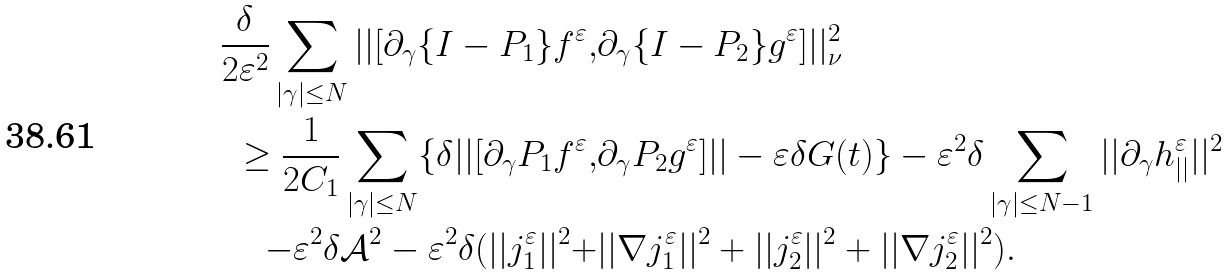Convert formula to latex. <formula><loc_0><loc_0><loc_500><loc_500>\frac { \delta } { 2 \varepsilon ^ { 2 } } \sum _ { | \gamma | \leq N } | | [ \partial _ { \gamma } { \{ I - P _ { 1 } \} f ^ { \varepsilon } } , & \partial _ { \gamma } { \{ I - P _ { 2 } \} g ^ { \varepsilon } } ] | | _ { \nu } ^ { 2 } \\ \geq \frac { 1 } { 2 C _ { 1 } } \sum _ { | \gamma | \leq N } \{ \delta | | [ \partial _ { \gamma } { P _ { 1 } f ^ { \varepsilon } } , & \partial _ { \gamma } { P _ { 2 } g ^ { \varepsilon } } ] | | - \varepsilon \delta G ( t ) \} - \varepsilon ^ { 2 } \delta \sum _ { | \gamma | \leq N - 1 } | | \partial _ { \gamma } h _ { | | } ^ { \varepsilon } | | ^ { 2 } \\ - \varepsilon ^ { 2 } \delta \mathcal { A } ^ { 2 } - \varepsilon ^ { 2 } \delta ( | | j _ { 1 } ^ { \varepsilon } | | ^ { 2 } + & | | \nabla j _ { 1 } ^ { \varepsilon } | | ^ { 2 } + | | j _ { 2 } ^ { \varepsilon } | | ^ { 2 } + | | \nabla j _ { 2 } ^ { \varepsilon } | | ^ { 2 } ) .</formula> 